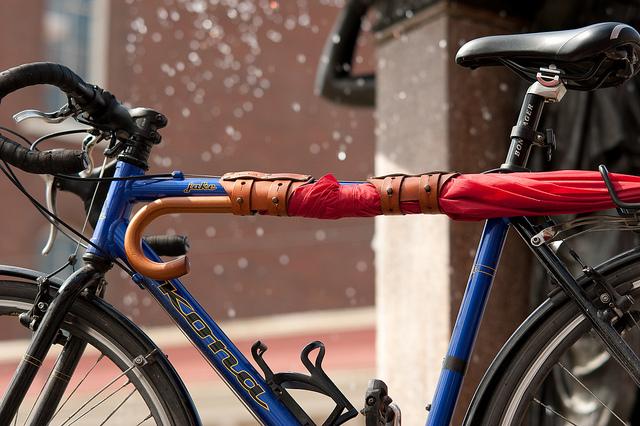What gender is the bicycle made for?
Give a very brief answer. Male. Is there a water bottle strapped to the bike?
Concise answer only. No. What is strapped to the bike?
Short answer required. Umbrella. How is the umbrella pointed to the bike?
Short answer required. To back. 